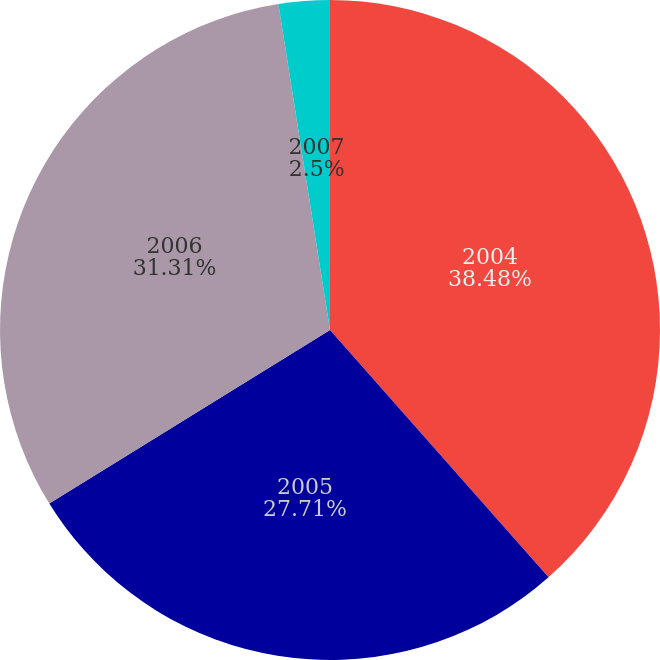Convert chart. <chart><loc_0><loc_0><loc_500><loc_500><pie_chart><fcel>2004<fcel>2005<fcel>2006<fcel>2007<nl><fcel>38.48%<fcel>27.71%<fcel>31.31%<fcel>2.5%<nl></chart> 